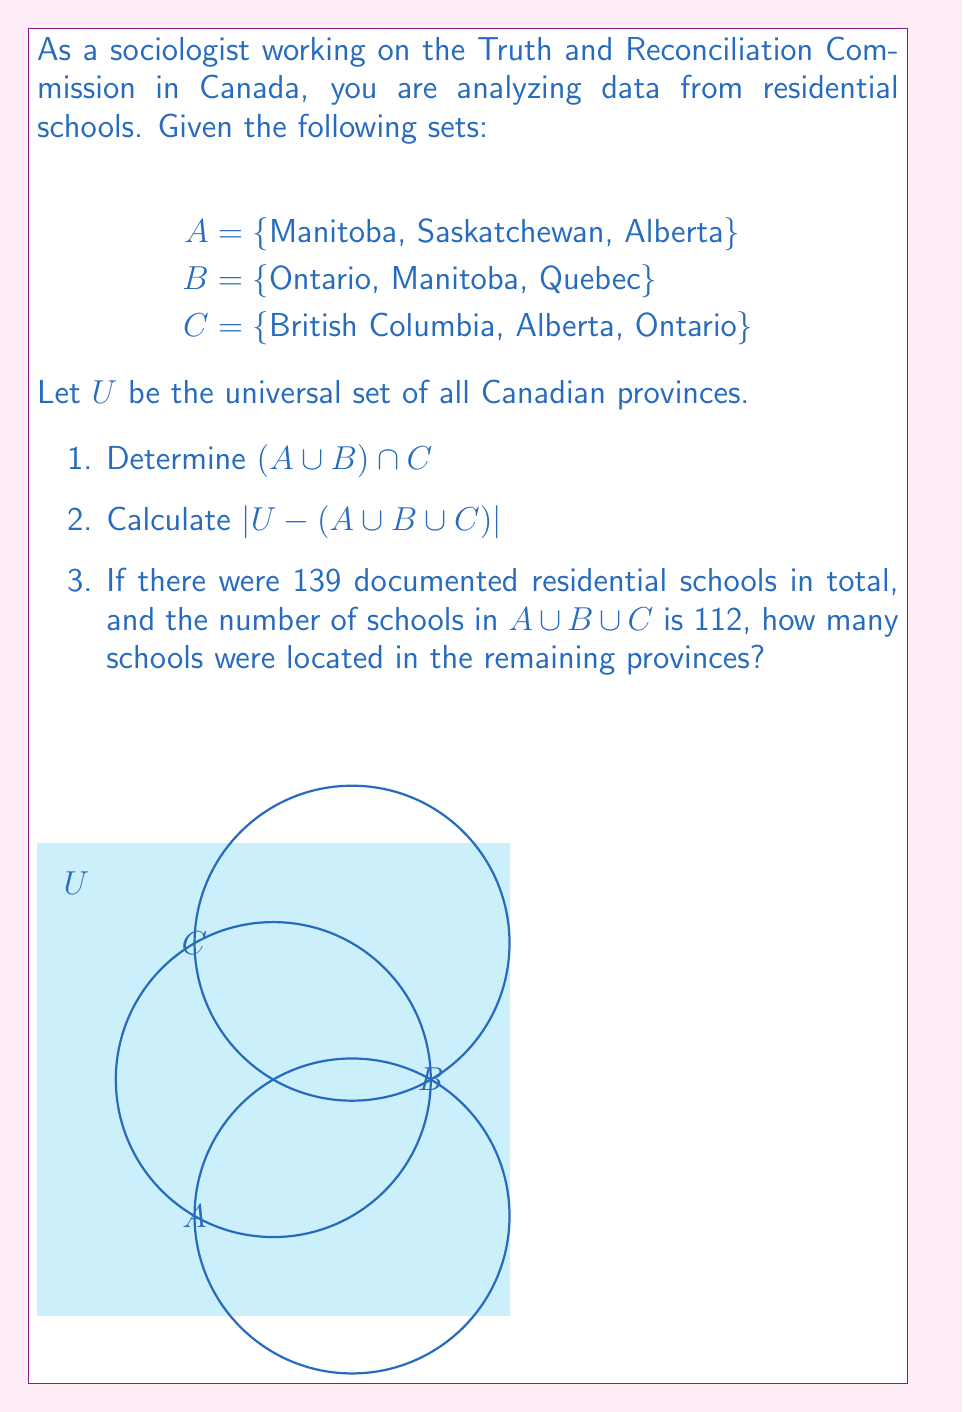Teach me how to tackle this problem. Let's approach this step-by-step:

1. To find $(A \cup B) \cap C$:
   a) First, we find $A \cup B = \{Manitoba, Saskatchewan, Alberta, Ontario, Quebec\}$
   b) Then, we intersect this with C:
      $(A \cup B) \cap C = \{Alberta, Ontario\}$

2. To calculate $|U - (A \cup B \cup C)|$:
   a) First, let's find $A \cup B \cup C = \{Manitoba, Saskatchewan, Alberta, Ontario, Quebec, British Columbia\}$
   b) The universal set U contains all 10 Canadian provinces
   c) $U - (A \cup B \cup C) = \{New Brunswick, Newfoundland and Labrador, Nova Scotia, Prince Edward Island\}$
   d) Therefore, $|U - (A \cup B \cup C)| = 4$

3. For the number of schools in the remaining provinces:
   a) Total schools = 139
   b) Schools in $A \cup B \cup C = 112$
   c) Schools in remaining provinces = 139 - 112 = 27

This analysis helps categorize the distribution of residential schools across different sets of provinces, providing valuable insights for the Truth and Reconciliation Commission's work.
Answer: 1. $\{Alberta, Ontario\}$
2. 4
3. 27 